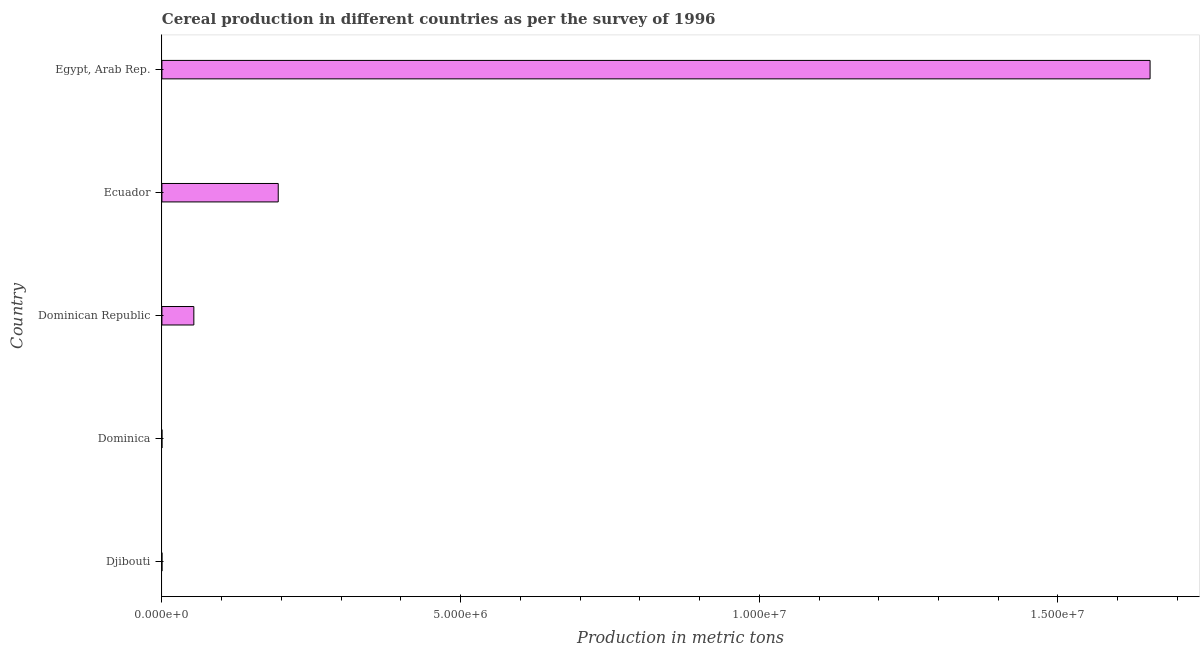Does the graph contain any zero values?
Your answer should be compact. No. Does the graph contain grids?
Your answer should be compact. No. What is the title of the graph?
Your answer should be very brief. Cereal production in different countries as per the survey of 1996. What is the label or title of the X-axis?
Offer a terse response. Production in metric tons. What is the cereal production in Dominican Republic?
Provide a succinct answer. 5.35e+05. Across all countries, what is the maximum cereal production?
Your answer should be compact. 1.65e+07. In which country was the cereal production maximum?
Keep it short and to the point. Egypt, Arab Rep. In which country was the cereal production minimum?
Ensure brevity in your answer.  Djibouti. What is the sum of the cereal production?
Offer a very short reply. 1.90e+07. What is the difference between the cereal production in Djibouti and Dominican Republic?
Your answer should be very brief. -5.35e+05. What is the average cereal production per country?
Your answer should be very brief. 3.80e+06. What is the median cereal production?
Your answer should be compact. 5.35e+05. In how many countries, is the cereal production greater than 6000000 metric tons?
Your answer should be very brief. 1. What is the ratio of the cereal production in Dominican Republic to that in Egypt, Arab Rep.?
Offer a very short reply. 0.03. What is the difference between the highest and the second highest cereal production?
Give a very brief answer. 1.46e+07. What is the difference between the highest and the lowest cereal production?
Ensure brevity in your answer.  1.65e+07. In how many countries, is the cereal production greater than the average cereal production taken over all countries?
Your answer should be compact. 1. Are all the bars in the graph horizontal?
Ensure brevity in your answer.  Yes. Are the values on the major ticks of X-axis written in scientific E-notation?
Your answer should be compact. Yes. What is the Production in metric tons of Dominica?
Offer a terse response. 217. What is the Production in metric tons in Dominican Republic?
Ensure brevity in your answer.  5.35e+05. What is the Production in metric tons of Ecuador?
Keep it short and to the point. 1.95e+06. What is the Production in metric tons of Egypt, Arab Rep.?
Make the answer very short. 1.65e+07. What is the difference between the Production in metric tons in Djibouti and Dominica?
Offer a very short reply. -205. What is the difference between the Production in metric tons in Djibouti and Dominican Republic?
Give a very brief answer. -5.35e+05. What is the difference between the Production in metric tons in Djibouti and Ecuador?
Ensure brevity in your answer.  -1.95e+06. What is the difference between the Production in metric tons in Djibouti and Egypt, Arab Rep.?
Provide a succinct answer. -1.65e+07. What is the difference between the Production in metric tons in Dominica and Dominican Republic?
Provide a short and direct response. -5.35e+05. What is the difference between the Production in metric tons in Dominica and Ecuador?
Ensure brevity in your answer.  -1.95e+06. What is the difference between the Production in metric tons in Dominica and Egypt, Arab Rep.?
Keep it short and to the point. -1.65e+07. What is the difference between the Production in metric tons in Dominican Republic and Ecuador?
Your response must be concise. -1.41e+06. What is the difference between the Production in metric tons in Dominican Republic and Egypt, Arab Rep.?
Your response must be concise. -1.60e+07. What is the difference between the Production in metric tons in Ecuador and Egypt, Arab Rep.?
Offer a terse response. -1.46e+07. What is the ratio of the Production in metric tons in Djibouti to that in Dominica?
Offer a very short reply. 0.06. What is the ratio of the Production in metric tons in Dominican Republic to that in Ecuador?
Your answer should be very brief. 0.28. What is the ratio of the Production in metric tons in Dominican Republic to that in Egypt, Arab Rep.?
Offer a terse response. 0.03. What is the ratio of the Production in metric tons in Ecuador to that in Egypt, Arab Rep.?
Offer a very short reply. 0.12. 